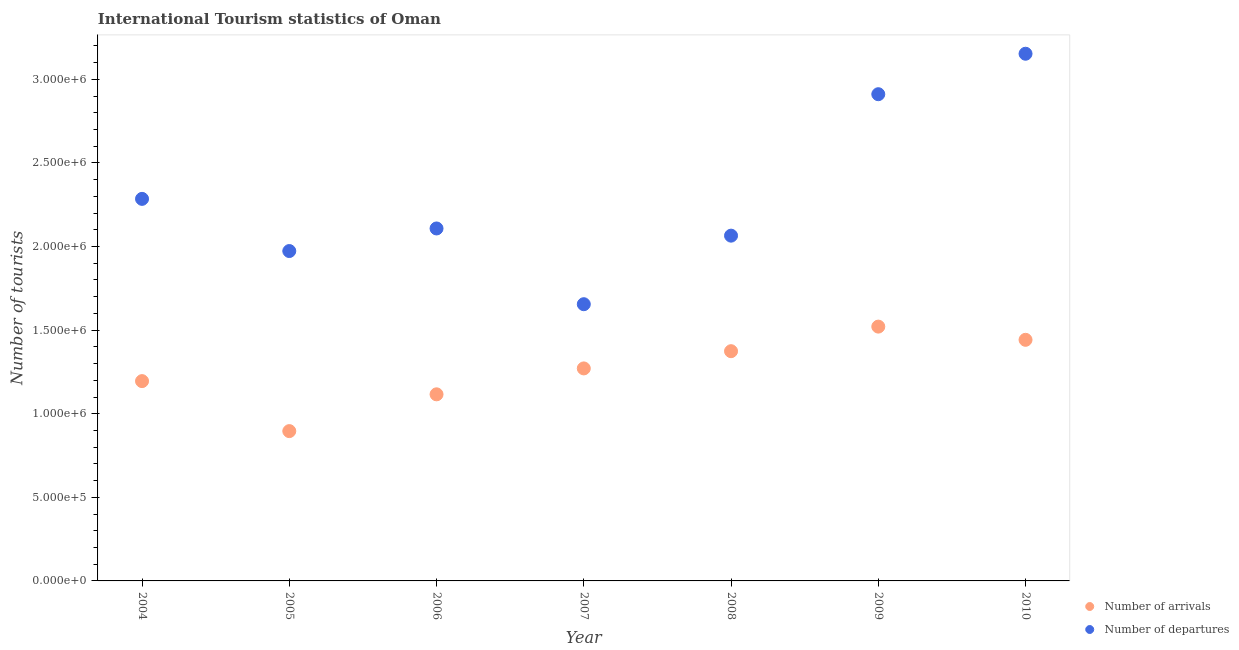How many different coloured dotlines are there?
Your response must be concise. 2. Is the number of dotlines equal to the number of legend labels?
Offer a terse response. Yes. What is the number of tourist arrivals in 2006?
Your answer should be compact. 1.12e+06. Across all years, what is the maximum number of tourist departures?
Give a very brief answer. 3.15e+06. Across all years, what is the minimum number of tourist arrivals?
Offer a terse response. 8.96e+05. In which year was the number of tourist departures maximum?
Keep it short and to the point. 2010. What is the total number of tourist arrivals in the graph?
Ensure brevity in your answer.  8.82e+06. What is the difference between the number of tourist arrivals in 2007 and that in 2010?
Provide a succinct answer. -1.71e+05. What is the difference between the number of tourist departures in 2009 and the number of tourist arrivals in 2008?
Offer a very short reply. 1.54e+06. What is the average number of tourist departures per year?
Provide a short and direct response. 2.31e+06. In the year 2008, what is the difference between the number of tourist arrivals and number of tourist departures?
Give a very brief answer. -6.91e+05. In how many years, is the number of tourist arrivals greater than 200000?
Your answer should be very brief. 7. What is the ratio of the number of tourist arrivals in 2004 to that in 2006?
Give a very brief answer. 1.07. Is the number of tourist departures in 2004 less than that in 2010?
Give a very brief answer. Yes. Is the difference between the number of tourist arrivals in 2005 and 2008 greater than the difference between the number of tourist departures in 2005 and 2008?
Provide a succinct answer. No. What is the difference between the highest and the second highest number of tourist departures?
Your response must be concise. 2.42e+05. What is the difference between the highest and the lowest number of tourist departures?
Provide a succinct answer. 1.50e+06. In how many years, is the number of tourist departures greater than the average number of tourist departures taken over all years?
Your answer should be very brief. 2. Is the sum of the number of tourist arrivals in 2004 and 2006 greater than the maximum number of tourist departures across all years?
Provide a succinct answer. No. Does the number of tourist departures monotonically increase over the years?
Keep it short and to the point. No. Is the number of tourist arrivals strictly greater than the number of tourist departures over the years?
Provide a succinct answer. No. Is the number of tourist arrivals strictly less than the number of tourist departures over the years?
Give a very brief answer. Yes. How many years are there in the graph?
Make the answer very short. 7. What is the difference between two consecutive major ticks on the Y-axis?
Ensure brevity in your answer.  5.00e+05. Are the values on the major ticks of Y-axis written in scientific E-notation?
Your answer should be very brief. Yes. Does the graph contain grids?
Give a very brief answer. No. Where does the legend appear in the graph?
Your response must be concise. Bottom right. What is the title of the graph?
Offer a very short reply. International Tourism statistics of Oman. Does "By country of asylum" appear as one of the legend labels in the graph?
Provide a short and direct response. No. What is the label or title of the Y-axis?
Your answer should be very brief. Number of tourists. What is the Number of tourists in Number of arrivals in 2004?
Your answer should be compact. 1.20e+06. What is the Number of tourists of Number of departures in 2004?
Provide a succinct answer. 2.28e+06. What is the Number of tourists of Number of arrivals in 2005?
Provide a short and direct response. 8.96e+05. What is the Number of tourists in Number of departures in 2005?
Provide a succinct answer. 1.97e+06. What is the Number of tourists of Number of arrivals in 2006?
Keep it short and to the point. 1.12e+06. What is the Number of tourists in Number of departures in 2006?
Ensure brevity in your answer.  2.11e+06. What is the Number of tourists in Number of arrivals in 2007?
Make the answer very short. 1.27e+06. What is the Number of tourists in Number of departures in 2007?
Ensure brevity in your answer.  1.66e+06. What is the Number of tourists in Number of arrivals in 2008?
Your response must be concise. 1.37e+06. What is the Number of tourists of Number of departures in 2008?
Offer a very short reply. 2.06e+06. What is the Number of tourists in Number of arrivals in 2009?
Ensure brevity in your answer.  1.52e+06. What is the Number of tourists in Number of departures in 2009?
Provide a succinct answer. 2.91e+06. What is the Number of tourists in Number of arrivals in 2010?
Your answer should be very brief. 1.44e+06. What is the Number of tourists in Number of departures in 2010?
Provide a short and direct response. 3.15e+06. Across all years, what is the maximum Number of tourists of Number of arrivals?
Give a very brief answer. 1.52e+06. Across all years, what is the maximum Number of tourists in Number of departures?
Offer a very short reply. 3.15e+06. Across all years, what is the minimum Number of tourists of Number of arrivals?
Your response must be concise. 8.96e+05. Across all years, what is the minimum Number of tourists of Number of departures?
Ensure brevity in your answer.  1.66e+06. What is the total Number of tourists of Number of arrivals in the graph?
Offer a terse response. 8.82e+06. What is the total Number of tourists of Number of departures in the graph?
Offer a terse response. 1.62e+07. What is the difference between the Number of tourists of Number of arrivals in 2004 and that in 2005?
Your answer should be very brief. 2.99e+05. What is the difference between the Number of tourists in Number of departures in 2004 and that in 2005?
Offer a terse response. 3.12e+05. What is the difference between the Number of tourists of Number of arrivals in 2004 and that in 2006?
Make the answer very short. 7.90e+04. What is the difference between the Number of tourists of Number of departures in 2004 and that in 2006?
Your answer should be compact. 1.77e+05. What is the difference between the Number of tourists in Number of arrivals in 2004 and that in 2007?
Your response must be concise. -7.60e+04. What is the difference between the Number of tourists of Number of departures in 2004 and that in 2007?
Ensure brevity in your answer.  6.30e+05. What is the difference between the Number of tourists of Number of arrivals in 2004 and that in 2008?
Offer a terse response. -1.79e+05. What is the difference between the Number of tourists of Number of departures in 2004 and that in 2008?
Make the answer very short. 2.20e+05. What is the difference between the Number of tourists in Number of arrivals in 2004 and that in 2009?
Your response must be concise. -3.26e+05. What is the difference between the Number of tourists in Number of departures in 2004 and that in 2009?
Make the answer very short. -6.26e+05. What is the difference between the Number of tourists in Number of arrivals in 2004 and that in 2010?
Offer a terse response. -2.47e+05. What is the difference between the Number of tourists of Number of departures in 2004 and that in 2010?
Offer a terse response. -8.68e+05. What is the difference between the Number of tourists of Number of arrivals in 2005 and that in 2006?
Keep it short and to the point. -2.20e+05. What is the difference between the Number of tourists in Number of departures in 2005 and that in 2006?
Ensure brevity in your answer.  -1.35e+05. What is the difference between the Number of tourists in Number of arrivals in 2005 and that in 2007?
Your answer should be very brief. -3.75e+05. What is the difference between the Number of tourists of Number of departures in 2005 and that in 2007?
Offer a terse response. 3.18e+05. What is the difference between the Number of tourists in Number of arrivals in 2005 and that in 2008?
Ensure brevity in your answer.  -4.78e+05. What is the difference between the Number of tourists in Number of departures in 2005 and that in 2008?
Your answer should be compact. -9.20e+04. What is the difference between the Number of tourists of Number of arrivals in 2005 and that in 2009?
Provide a succinct answer. -6.25e+05. What is the difference between the Number of tourists in Number of departures in 2005 and that in 2009?
Give a very brief answer. -9.38e+05. What is the difference between the Number of tourists in Number of arrivals in 2005 and that in 2010?
Your answer should be compact. -5.46e+05. What is the difference between the Number of tourists in Number of departures in 2005 and that in 2010?
Offer a very short reply. -1.18e+06. What is the difference between the Number of tourists in Number of arrivals in 2006 and that in 2007?
Ensure brevity in your answer.  -1.55e+05. What is the difference between the Number of tourists in Number of departures in 2006 and that in 2007?
Your response must be concise. 4.53e+05. What is the difference between the Number of tourists in Number of arrivals in 2006 and that in 2008?
Your answer should be very brief. -2.58e+05. What is the difference between the Number of tourists in Number of departures in 2006 and that in 2008?
Your response must be concise. 4.30e+04. What is the difference between the Number of tourists of Number of arrivals in 2006 and that in 2009?
Your answer should be compact. -4.05e+05. What is the difference between the Number of tourists in Number of departures in 2006 and that in 2009?
Provide a short and direct response. -8.03e+05. What is the difference between the Number of tourists in Number of arrivals in 2006 and that in 2010?
Give a very brief answer. -3.26e+05. What is the difference between the Number of tourists in Number of departures in 2006 and that in 2010?
Keep it short and to the point. -1.04e+06. What is the difference between the Number of tourists of Number of arrivals in 2007 and that in 2008?
Offer a terse response. -1.03e+05. What is the difference between the Number of tourists of Number of departures in 2007 and that in 2008?
Give a very brief answer. -4.10e+05. What is the difference between the Number of tourists in Number of departures in 2007 and that in 2009?
Provide a succinct answer. -1.26e+06. What is the difference between the Number of tourists of Number of arrivals in 2007 and that in 2010?
Give a very brief answer. -1.71e+05. What is the difference between the Number of tourists in Number of departures in 2007 and that in 2010?
Give a very brief answer. -1.50e+06. What is the difference between the Number of tourists of Number of arrivals in 2008 and that in 2009?
Give a very brief answer. -1.47e+05. What is the difference between the Number of tourists in Number of departures in 2008 and that in 2009?
Your answer should be very brief. -8.46e+05. What is the difference between the Number of tourists of Number of arrivals in 2008 and that in 2010?
Give a very brief answer. -6.80e+04. What is the difference between the Number of tourists of Number of departures in 2008 and that in 2010?
Keep it short and to the point. -1.09e+06. What is the difference between the Number of tourists in Number of arrivals in 2009 and that in 2010?
Keep it short and to the point. 7.90e+04. What is the difference between the Number of tourists of Number of departures in 2009 and that in 2010?
Keep it short and to the point. -2.42e+05. What is the difference between the Number of tourists of Number of arrivals in 2004 and the Number of tourists of Number of departures in 2005?
Give a very brief answer. -7.78e+05. What is the difference between the Number of tourists of Number of arrivals in 2004 and the Number of tourists of Number of departures in 2006?
Offer a terse response. -9.13e+05. What is the difference between the Number of tourists in Number of arrivals in 2004 and the Number of tourists in Number of departures in 2007?
Provide a short and direct response. -4.60e+05. What is the difference between the Number of tourists in Number of arrivals in 2004 and the Number of tourists in Number of departures in 2008?
Give a very brief answer. -8.70e+05. What is the difference between the Number of tourists in Number of arrivals in 2004 and the Number of tourists in Number of departures in 2009?
Make the answer very short. -1.72e+06. What is the difference between the Number of tourists of Number of arrivals in 2004 and the Number of tourists of Number of departures in 2010?
Your answer should be very brief. -1.96e+06. What is the difference between the Number of tourists in Number of arrivals in 2005 and the Number of tourists in Number of departures in 2006?
Provide a short and direct response. -1.21e+06. What is the difference between the Number of tourists of Number of arrivals in 2005 and the Number of tourists of Number of departures in 2007?
Provide a succinct answer. -7.59e+05. What is the difference between the Number of tourists of Number of arrivals in 2005 and the Number of tourists of Number of departures in 2008?
Your answer should be very brief. -1.17e+06. What is the difference between the Number of tourists in Number of arrivals in 2005 and the Number of tourists in Number of departures in 2009?
Your response must be concise. -2.02e+06. What is the difference between the Number of tourists in Number of arrivals in 2005 and the Number of tourists in Number of departures in 2010?
Offer a very short reply. -2.26e+06. What is the difference between the Number of tourists in Number of arrivals in 2006 and the Number of tourists in Number of departures in 2007?
Your answer should be very brief. -5.39e+05. What is the difference between the Number of tourists in Number of arrivals in 2006 and the Number of tourists in Number of departures in 2008?
Ensure brevity in your answer.  -9.49e+05. What is the difference between the Number of tourists of Number of arrivals in 2006 and the Number of tourists of Number of departures in 2009?
Give a very brief answer. -1.80e+06. What is the difference between the Number of tourists in Number of arrivals in 2006 and the Number of tourists in Number of departures in 2010?
Your answer should be compact. -2.04e+06. What is the difference between the Number of tourists of Number of arrivals in 2007 and the Number of tourists of Number of departures in 2008?
Make the answer very short. -7.94e+05. What is the difference between the Number of tourists of Number of arrivals in 2007 and the Number of tourists of Number of departures in 2009?
Offer a terse response. -1.64e+06. What is the difference between the Number of tourists in Number of arrivals in 2007 and the Number of tourists in Number of departures in 2010?
Keep it short and to the point. -1.88e+06. What is the difference between the Number of tourists of Number of arrivals in 2008 and the Number of tourists of Number of departures in 2009?
Ensure brevity in your answer.  -1.54e+06. What is the difference between the Number of tourists in Number of arrivals in 2008 and the Number of tourists in Number of departures in 2010?
Keep it short and to the point. -1.78e+06. What is the difference between the Number of tourists in Number of arrivals in 2009 and the Number of tourists in Number of departures in 2010?
Your response must be concise. -1.63e+06. What is the average Number of tourists of Number of arrivals per year?
Give a very brief answer. 1.26e+06. What is the average Number of tourists in Number of departures per year?
Ensure brevity in your answer.  2.31e+06. In the year 2004, what is the difference between the Number of tourists of Number of arrivals and Number of tourists of Number of departures?
Make the answer very short. -1.09e+06. In the year 2005, what is the difference between the Number of tourists of Number of arrivals and Number of tourists of Number of departures?
Provide a succinct answer. -1.08e+06. In the year 2006, what is the difference between the Number of tourists of Number of arrivals and Number of tourists of Number of departures?
Ensure brevity in your answer.  -9.92e+05. In the year 2007, what is the difference between the Number of tourists of Number of arrivals and Number of tourists of Number of departures?
Give a very brief answer. -3.84e+05. In the year 2008, what is the difference between the Number of tourists in Number of arrivals and Number of tourists in Number of departures?
Your answer should be compact. -6.91e+05. In the year 2009, what is the difference between the Number of tourists of Number of arrivals and Number of tourists of Number of departures?
Your answer should be compact. -1.39e+06. In the year 2010, what is the difference between the Number of tourists in Number of arrivals and Number of tourists in Number of departures?
Provide a succinct answer. -1.71e+06. What is the ratio of the Number of tourists of Number of arrivals in 2004 to that in 2005?
Provide a succinct answer. 1.33. What is the ratio of the Number of tourists of Number of departures in 2004 to that in 2005?
Keep it short and to the point. 1.16. What is the ratio of the Number of tourists in Number of arrivals in 2004 to that in 2006?
Your answer should be compact. 1.07. What is the ratio of the Number of tourists in Number of departures in 2004 to that in 2006?
Your answer should be very brief. 1.08. What is the ratio of the Number of tourists of Number of arrivals in 2004 to that in 2007?
Provide a short and direct response. 0.94. What is the ratio of the Number of tourists in Number of departures in 2004 to that in 2007?
Keep it short and to the point. 1.38. What is the ratio of the Number of tourists of Number of arrivals in 2004 to that in 2008?
Offer a very short reply. 0.87. What is the ratio of the Number of tourists in Number of departures in 2004 to that in 2008?
Ensure brevity in your answer.  1.11. What is the ratio of the Number of tourists of Number of arrivals in 2004 to that in 2009?
Give a very brief answer. 0.79. What is the ratio of the Number of tourists of Number of departures in 2004 to that in 2009?
Your response must be concise. 0.79. What is the ratio of the Number of tourists in Number of arrivals in 2004 to that in 2010?
Your response must be concise. 0.83. What is the ratio of the Number of tourists of Number of departures in 2004 to that in 2010?
Make the answer very short. 0.72. What is the ratio of the Number of tourists of Number of arrivals in 2005 to that in 2006?
Keep it short and to the point. 0.8. What is the ratio of the Number of tourists in Number of departures in 2005 to that in 2006?
Provide a succinct answer. 0.94. What is the ratio of the Number of tourists of Number of arrivals in 2005 to that in 2007?
Ensure brevity in your answer.  0.7. What is the ratio of the Number of tourists in Number of departures in 2005 to that in 2007?
Give a very brief answer. 1.19. What is the ratio of the Number of tourists in Number of arrivals in 2005 to that in 2008?
Ensure brevity in your answer.  0.65. What is the ratio of the Number of tourists in Number of departures in 2005 to that in 2008?
Ensure brevity in your answer.  0.96. What is the ratio of the Number of tourists in Number of arrivals in 2005 to that in 2009?
Keep it short and to the point. 0.59. What is the ratio of the Number of tourists of Number of departures in 2005 to that in 2009?
Offer a very short reply. 0.68. What is the ratio of the Number of tourists in Number of arrivals in 2005 to that in 2010?
Your response must be concise. 0.62. What is the ratio of the Number of tourists in Number of departures in 2005 to that in 2010?
Your response must be concise. 0.63. What is the ratio of the Number of tourists in Number of arrivals in 2006 to that in 2007?
Provide a short and direct response. 0.88. What is the ratio of the Number of tourists in Number of departures in 2006 to that in 2007?
Keep it short and to the point. 1.27. What is the ratio of the Number of tourists in Number of arrivals in 2006 to that in 2008?
Your answer should be compact. 0.81. What is the ratio of the Number of tourists in Number of departures in 2006 to that in 2008?
Offer a very short reply. 1.02. What is the ratio of the Number of tourists in Number of arrivals in 2006 to that in 2009?
Offer a terse response. 0.73. What is the ratio of the Number of tourists of Number of departures in 2006 to that in 2009?
Your response must be concise. 0.72. What is the ratio of the Number of tourists in Number of arrivals in 2006 to that in 2010?
Your answer should be very brief. 0.77. What is the ratio of the Number of tourists in Number of departures in 2006 to that in 2010?
Your response must be concise. 0.67. What is the ratio of the Number of tourists in Number of arrivals in 2007 to that in 2008?
Offer a very short reply. 0.93. What is the ratio of the Number of tourists of Number of departures in 2007 to that in 2008?
Provide a short and direct response. 0.8. What is the ratio of the Number of tourists of Number of arrivals in 2007 to that in 2009?
Offer a very short reply. 0.84. What is the ratio of the Number of tourists of Number of departures in 2007 to that in 2009?
Your answer should be compact. 0.57. What is the ratio of the Number of tourists in Number of arrivals in 2007 to that in 2010?
Your answer should be compact. 0.88. What is the ratio of the Number of tourists of Number of departures in 2007 to that in 2010?
Offer a terse response. 0.52. What is the ratio of the Number of tourists of Number of arrivals in 2008 to that in 2009?
Your answer should be very brief. 0.9. What is the ratio of the Number of tourists of Number of departures in 2008 to that in 2009?
Your answer should be compact. 0.71. What is the ratio of the Number of tourists in Number of arrivals in 2008 to that in 2010?
Ensure brevity in your answer.  0.95. What is the ratio of the Number of tourists of Number of departures in 2008 to that in 2010?
Give a very brief answer. 0.65. What is the ratio of the Number of tourists of Number of arrivals in 2009 to that in 2010?
Provide a succinct answer. 1.05. What is the ratio of the Number of tourists of Number of departures in 2009 to that in 2010?
Provide a succinct answer. 0.92. What is the difference between the highest and the second highest Number of tourists in Number of arrivals?
Offer a very short reply. 7.90e+04. What is the difference between the highest and the second highest Number of tourists of Number of departures?
Provide a succinct answer. 2.42e+05. What is the difference between the highest and the lowest Number of tourists of Number of arrivals?
Keep it short and to the point. 6.25e+05. What is the difference between the highest and the lowest Number of tourists in Number of departures?
Your answer should be very brief. 1.50e+06. 